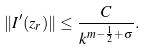Convert formula to latex. <formula><loc_0><loc_0><loc_500><loc_500>\| I ^ { \prime } ( z _ { r } ) \| \leq \frac { C } { k ^ { m - \frac { 1 } { 2 } + \sigma } } .</formula> 